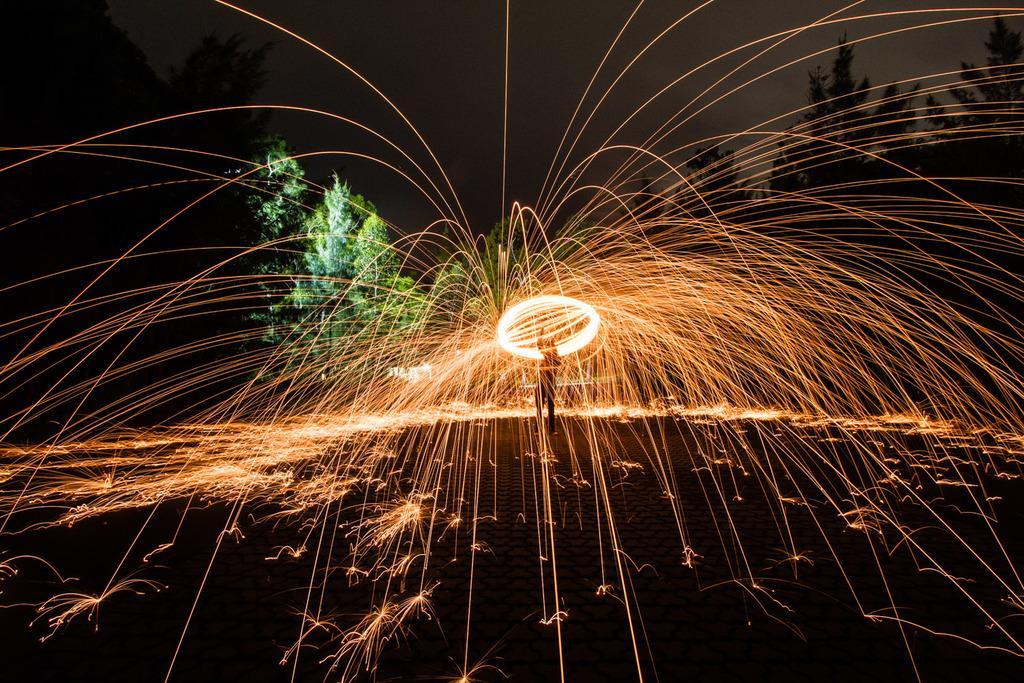Please provide a concise description of this image. In this image we can see, in the middle there is a person playing with fire and the background is the sky. 